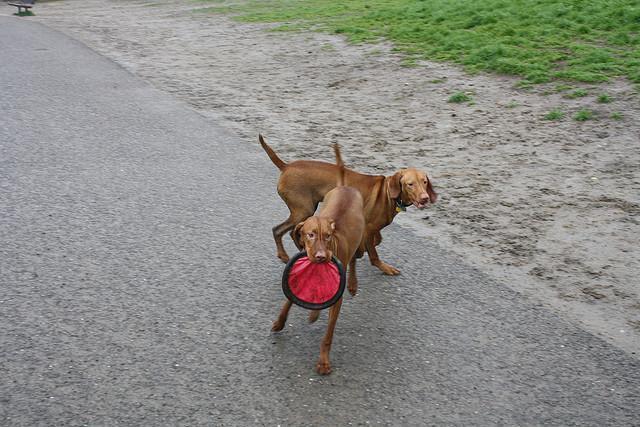How many dogs are visible?
Give a very brief answer. 2. 